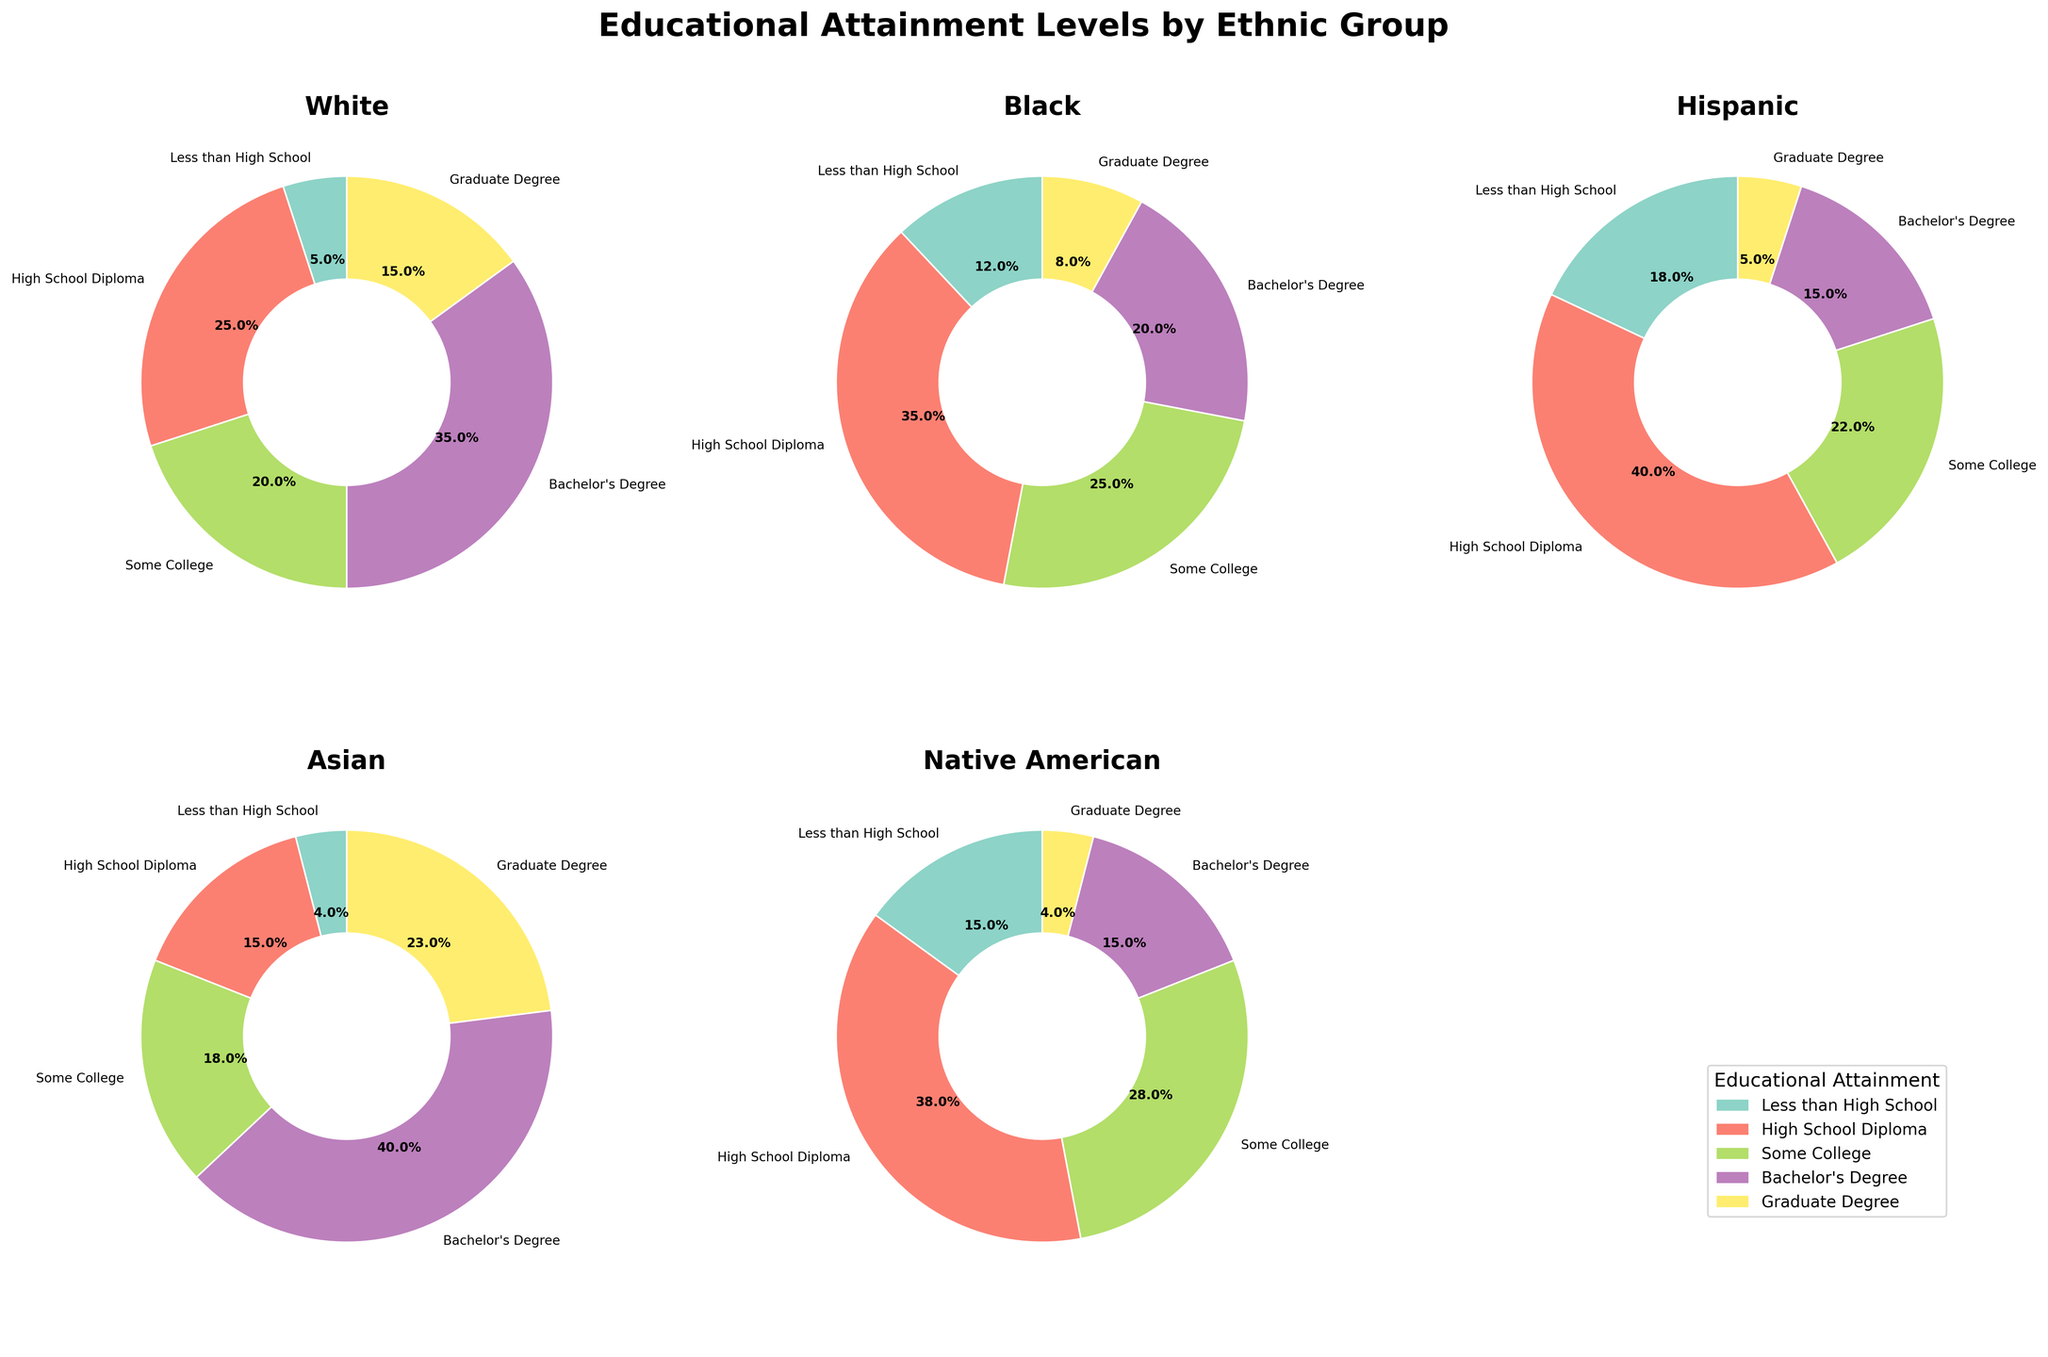Which ethnic group has the highest percentage of individuals with a Bachelor's Degree? To answer this, observe the segments labeled "Bachelor's Degree" in each pie chart. The Asian group has the largest segment for Bachelor's Degree at 40%.
Answer: Asian Which ethnic group has the lowest percentage of individuals with less than a High School education? Examine the segments labeled "Less than High School" in each chart. The Asian group has the smallest segment for this category at 4%.
Answer: Asian What is the sum of the percentage of Hispanics with Some College and those with a High School Diploma? Look at the pie chart for Hispanics and find the percentages for "Some College" (22%) and "High School Diploma" (40%). Summing them gives 22% + 40% = 62%.
Answer: 62% Compare the percentage of Whites and Hispanics with a Graduate Degree. Which group has a higher percentage and by how much? Check the percentages for "Graduate Degree" in both the White (15%) and Hispanic (5%) groups. Subtract the Hispanic percentage from the White percentage: 15% - 5% = 10%. Whites have a higher percentage by 10%.
Answer: Whites, by 10% What is the combined percentage of Native Americans with at least a Bachelor's Degree? Combine the percentages for "Bachelor's Degree" (15%) and "Graduate Degree" (4%) in the Native American group. The sum is 15% + 4% = 19%.
Answer: 19% Is the percentage of individuals with Some College higher in the Black group or the Native American group? By how much? Check the "Some College" percentages for Blacks (25%) and Native Americans (28%). The Native American group has a higher percentage, specifically by 28% - 25% = 3%.
Answer: Native Americans, by 3% Which educational attainment level among Whites has the smallest percentage? Look at the White group's pie chart and identify the smallest segment, which is "Less than High School" at 5%.
Answer: Less than High School How does the percentage of Hispanics with a High School Diploma compare to that of Blacks with the same level of education? Compare the "High School Diploma" segments in the Hispanic (40%) and Black (35%) pie charts. The Hispanic percentage is higher by 5%.
Answer: Hispanics have a higher percentage by 5% What is the average percentage of individuals with a Graduate Degree across all ethnic groups? Sum percentages of individuals with Graduate Degrees: White (15%), Black (8%), Hispanic (5%), Asian (23%), and Native American (4%). The total is 15% + 8% + 5% + 23% + 4% = 55%. Divide by 5 ethnic groups to get the average: 55% / 5 = 11%.
Answer: 11% Which ethnic group has the most balanced distribution across all educational attainment levels? The most balanced distribution is where the percentages are closer to each other among all categories. Observing the pie charts, the Black group has the most balanced segments (12%, 35%, 25%, 20%, 8%).
Answer: Black 